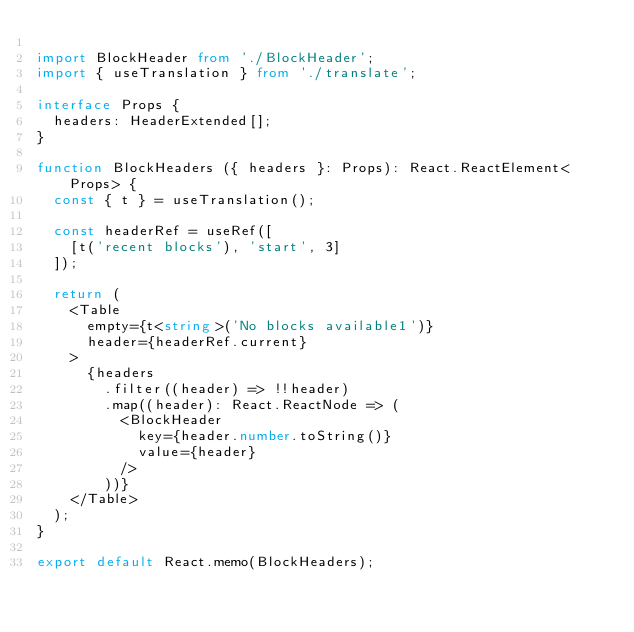Convert code to text. <code><loc_0><loc_0><loc_500><loc_500><_TypeScript_>
import BlockHeader from './BlockHeader';
import { useTranslation } from './translate';

interface Props {
  headers: HeaderExtended[];
}

function BlockHeaders ({ headers }: Props): React.ReactElement<Props> {
  const { t } = useTranslation();

  const headerRef = useRef([
    [t('recent blocks'), 'start', 3]
  ]);

  return (
    <Table
      empty={t<string>('No blocks available1')}
      header={headerRef.current}
    >
      {headers
        .filter((header) => !!header)
        .map((header): React.ReactNode => (
          <BlockHeader
            key={header.number.toString()}
            value={header}
          />
        ))}
    </Table>
  );
}

export default React.memo(BlockHeaders);
</code> 